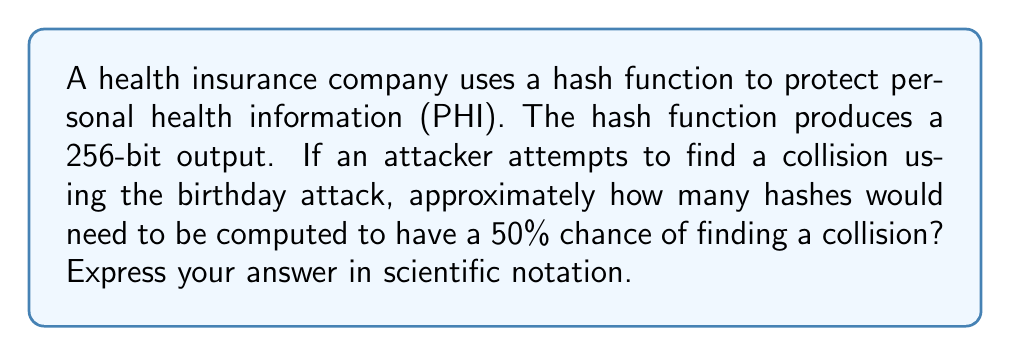Can you solve this math problem? To solve this problem, we'll follow these steps:

1) The birthday attack is based on the birthday paradox, which states that in a group of 23 people, there's about a 50% chance that two people share the same birthday.

2) For a hash function with an n-bit output, the number of hashes needed for a 50% chance of collision is approximately:

   $$\sqrt{2^n \cdot \ln(2)}$$

3) In this case, n = 256 bits.

4) Let's substitute this into our formula:

   $$\sqrt{2^{256} \cdot \ln(2)}$$

5) We can simplify this:
   
   $$\sqrt{2^{256} \cdot 0.693}$$

6) Now, let's calculate:

   $$\sqrt{2^{256} \cdot 0.693} \approx 1.1774 \times 10^{38}$$

7) This large number represents the approximate number of hashes that would need to be computed for a 50% chance of finding a collision.

This demonstrates the strength of a 256-bit hash function in protecting PHI, as it would require an enormous amount of computational power to find a collision, making it highly secure for short-term health insurance data.
Answer: $1.18 \times 10^{38}$ 